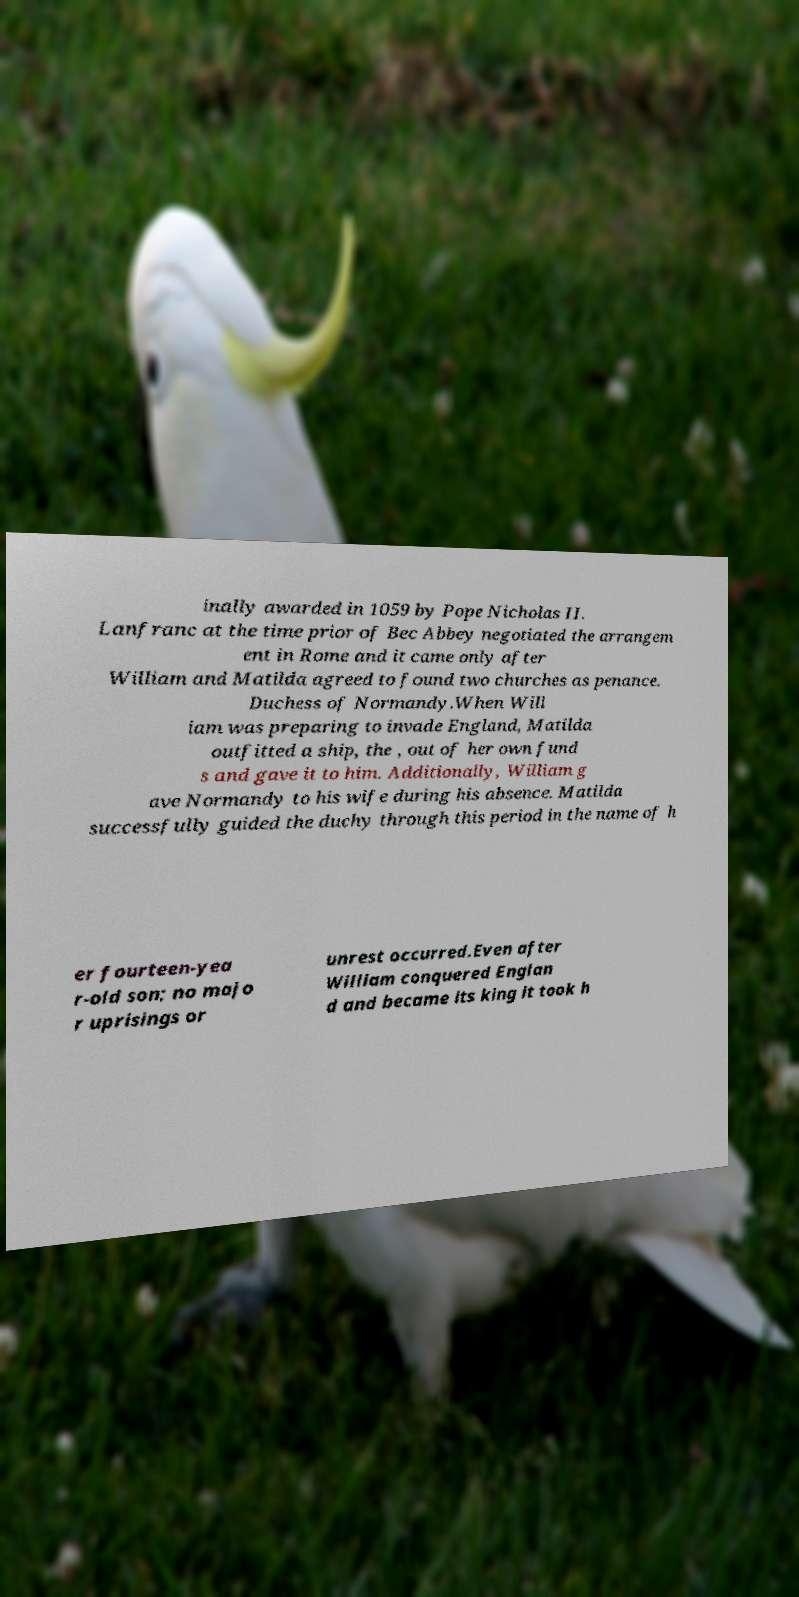Can you accurately transcribe the text from the provided image for me? inally awarded in 1059 by Pope Nicholas II. Lanfranc at the time prior of Bec Abbey negotiated the arrangem ent in Rome and it came only after William and Matilda agreed to found two churches as penance. Duchess of Normandy.When Will iam was preparing to invade England, Matilda outfitted a ship, the , out of her own fund s and gave it to him. Additionally, William g ave Normandy to his wife during his absence. Matilda successfully guided the duchy through this period in the name of h er fourteen-yea r-old son; no majo r uprisings or unrest occurred.Even after William conquered Englan d and became its king it took h 